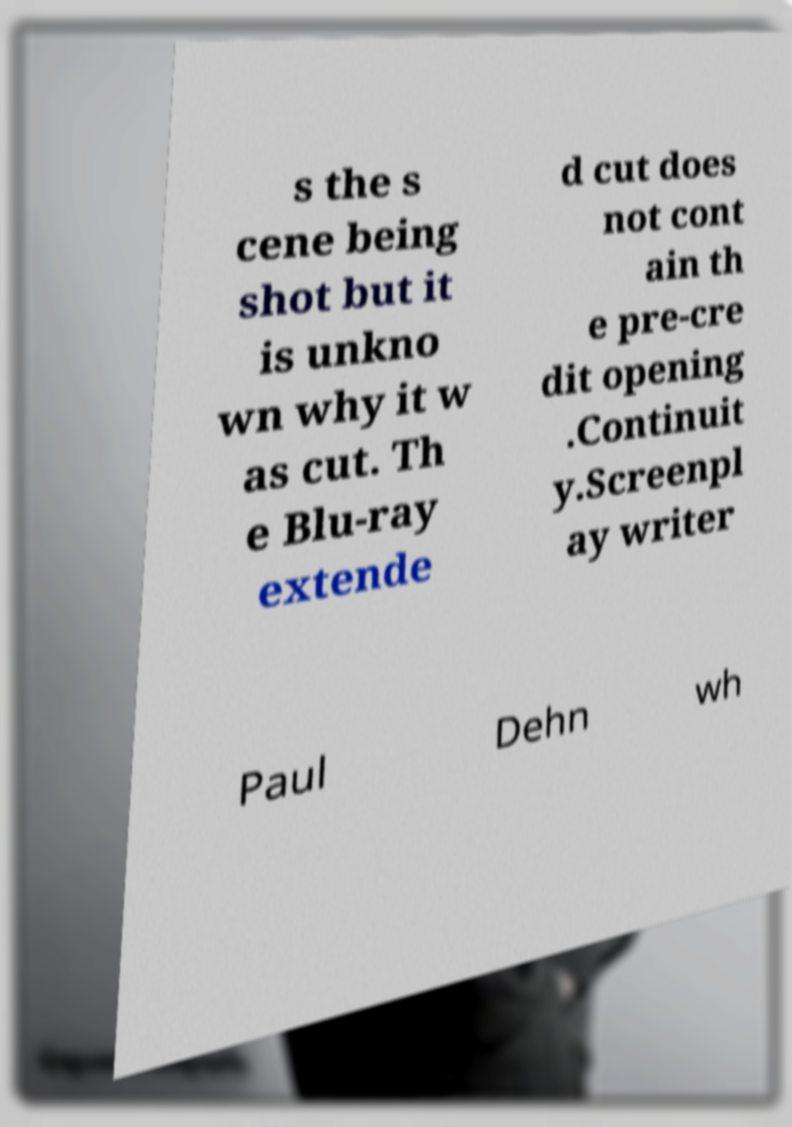Please identify and transcribe the text found in this image. s the s cene being shot but it is unkno wn why it w as cut. Th e Blu-ray extende d cut does not cont ain th e pre-cre dit opening .Continuit y.Screenpl ay writer Paul Dehn wh 